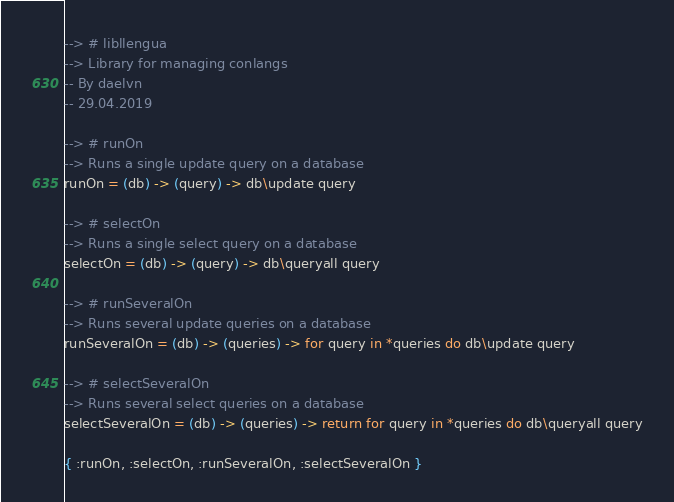Convert code to text. <code><loc_0><loc_0><loc_500><loc_500><_MoonScript_>--> # libllengua
--> Library for managing conlangs
-- By daelvn
-- 29.04.2019

--> # runOn
--> Runs a single update query on a database
runOn = (db) -> (query) -> db\update query

--> # selectOn
--> Runs a single select query on a database
selectOn = (db) -> (query) -> db\queryall query

--> # runSeveralOn
--> Runs several update queries on a database
runSeveralOn = (db) -> (queries) -> for query in *queries do db\update query

--> # selectSeveralOn
--> Runs several select queries on a database
selectSeveralOn = (db) -> (queries) -> return for query in *queries do db\queryall query

{ :runOn, :selectOn, :runSeveralOn, :selectSeveralOn }
</code> 